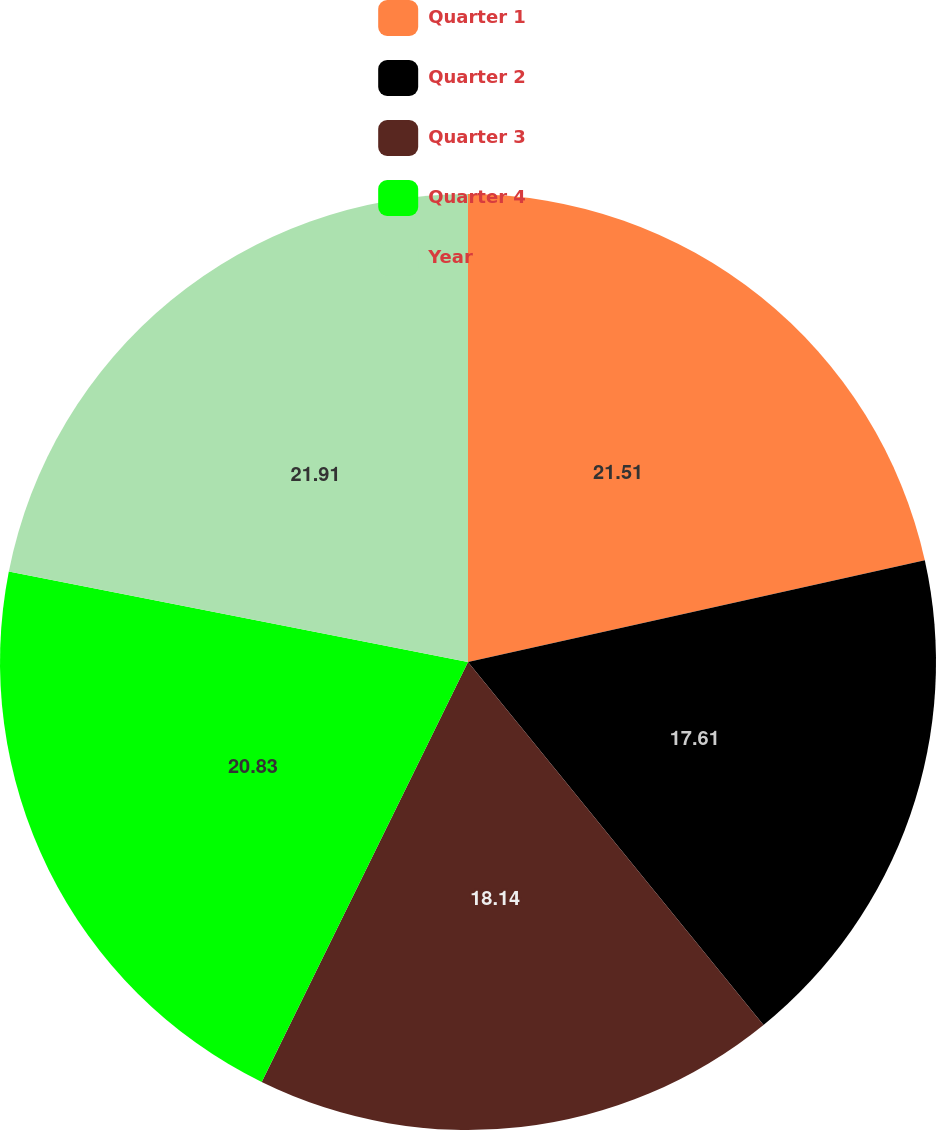Convert chart. <chart><loc_0><loc_0><loc_500><loc_500><pie_chart><fcel>Quarter 1<fcel>Quarter 2<fcel>Quarter 3<fcel>Quarter 4<fcel>Year<nl><fcel>21.51%<fcel>17.61%<fcel>18.14%<fcel>20.83%<fcel>21.9%<nl></chart> 